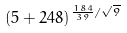Convert formula to latex. <formula><loc_0><loc_0><loc_500><loc_500>( 5 + 2 4 8 ) ^ { \frac { 1 8 4 } { 3 9 } / \sqrt { 9 } }</formula> 